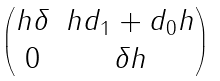<formula> <loc_0><loc_0><loc_500><loc_500>\begin{pmatrix} h \delta & h d _ { 1 } + d _ { 0 } h \\ 0 & \delta h \end{pmatrix}</formula> 